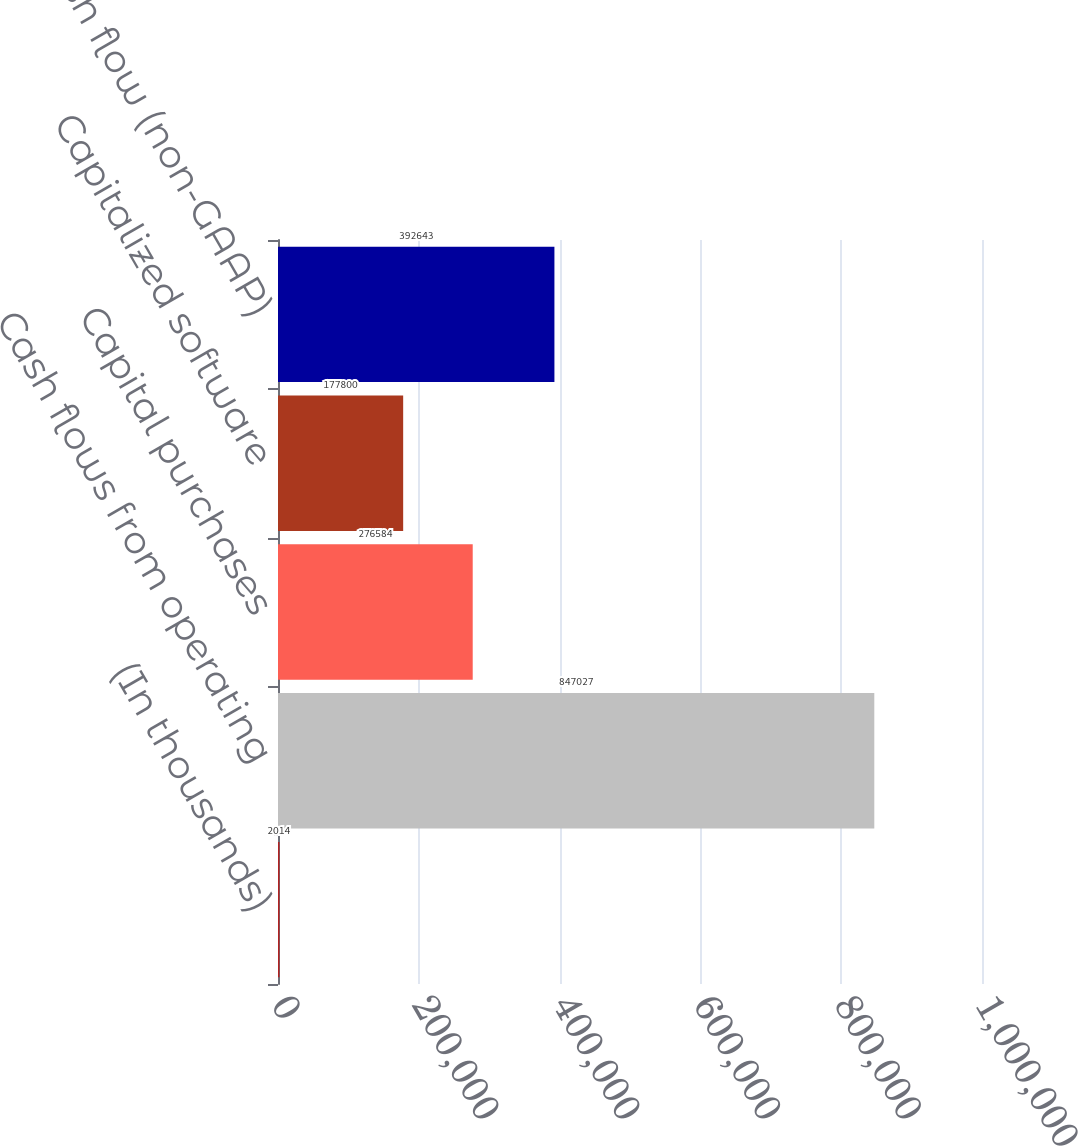<chart> <loc_0><loc_0><loc_500><loc_500><bar_chart><fcel>(In thousands)<fcel>Cash flows from operating<fcel>Capital purchases<fcel>Capitalized software<fcel>Free cash flow (non-GAAP)<nl><fcel>2014<fcel>847027<fcel>276584<fcel>177800<fcel>392643<nl></chart> 